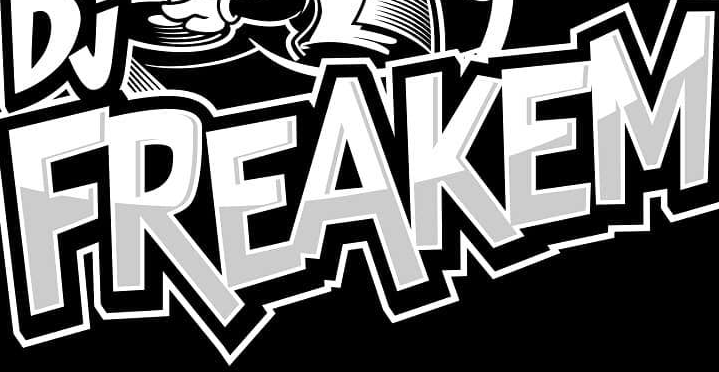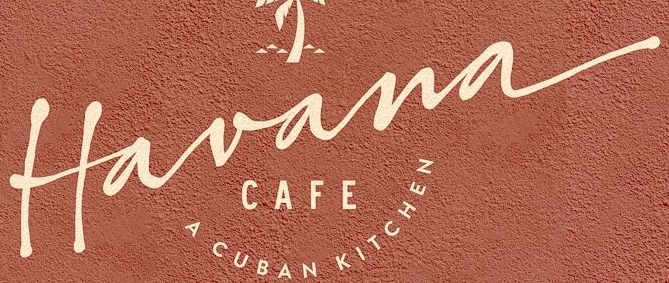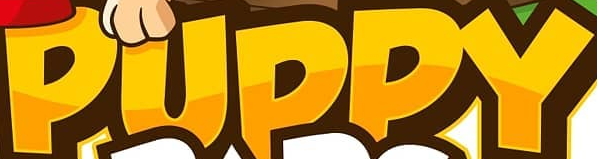What text is displayed in these images sequentially, separated by a semicolon? FREAKEM; Havana; PUPPY 